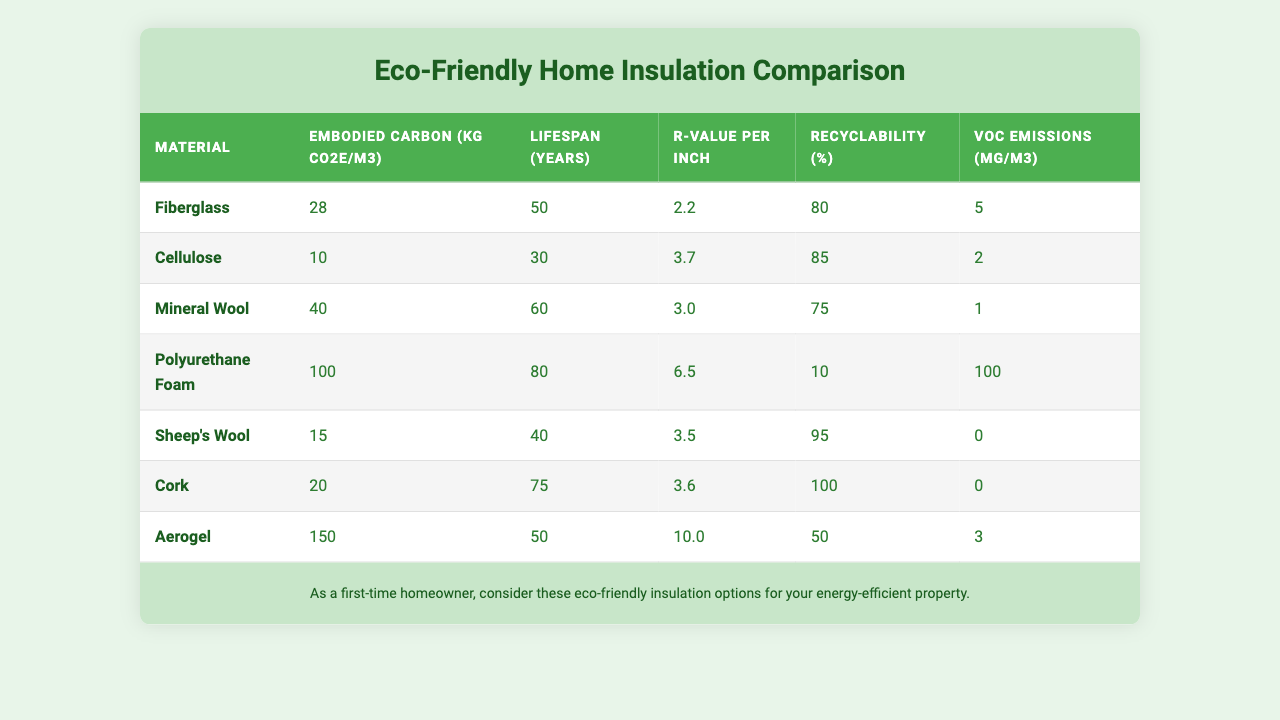What is the embodied carbon of Mineral Wool? According to the table, the embodied carbon of Mineral Wool is listed under the "Embodied Carbon" column, which shows a value of 40 kg CO2e/m3.
Answer: 40 kg CO2e/m3 Which insulation material has the highest recyclability percentage? By comparing the "Recyclability" column, Cork exhibits the highest at 100%, while the other materials have lower values.
Answer: Cork What is the average lifespan of all the insulation materials listed? To calculate the average lifespan, we sum all the lifespans: 50 + 30 + 60 + 80 + 40 + 75 + 50 = 385 years. There are 7 materials, so the average is 385 / 7 ≈ 55 years.
Answer: Approximately 55 years Is the VOC emission from Sheep's Wool higher than that from Cellulose? The table shows VOC emissions for Sheep's Wool is 0, whereas for Cellulose it is 2 µg/m3. Since 0 is not greater than 2, the answer is no.
Answer: No Which insulation material has the highest R-value per inch and what is its value? Looking at the "R-value per inch" column, Aerogel has the highest value at 10.0.
Answer: Aerogel, 10.0 If we combine the embodied carbon of Fiberglass and Cellulose, what does it total? The embodied carbon for Fiberglass is 28 kg CO2e/m3, and for Cellulose, it is 10 kg CO2e/m3. Adding these gives 28 + 10 = 38 kg CO2e/m3.
Answer: 38 kg CO2e/m3 What percentage of the insulation materials listed have a lifespan of over 50 years? The materials with lifespans over 50 years are Mineral Wool (60), Polyurethane Foam (80), and Cork (75), totaling 3 out of 7 materials; thus the percentage is (3/7) * 100 ≈ 42.86%.
Answer: Approximately 42.86% Is it true that Polyurethane Foam has the lowest recyclability percentage? From the table, Polyurethane Foam has a recyclability percentage of 10%, which is lower than that of all other materials, so this statement is true.
Answer: Yes What is the difference in VOC emissions between Aerogel and Polyurethane Foam? Aerogel has VOC emissions of 3 µg/m3 while Polyurethane Foam has 100 µg/m3. The difference is 100 - 3 = 97 µg/m3.
Answer: 97 µg/m3 If you want to reduce embodied carbon while maintaining good insulation, which two materials should you consider? The two materials with the lowest embodied carbon are Cellulose (10 kg CO2e/m3) and Sheep's Wool (15 kg CO2e/m3), which together provide an efficient option with lower carbon impact.
Answer: Cellulose and Sheep's Wool 